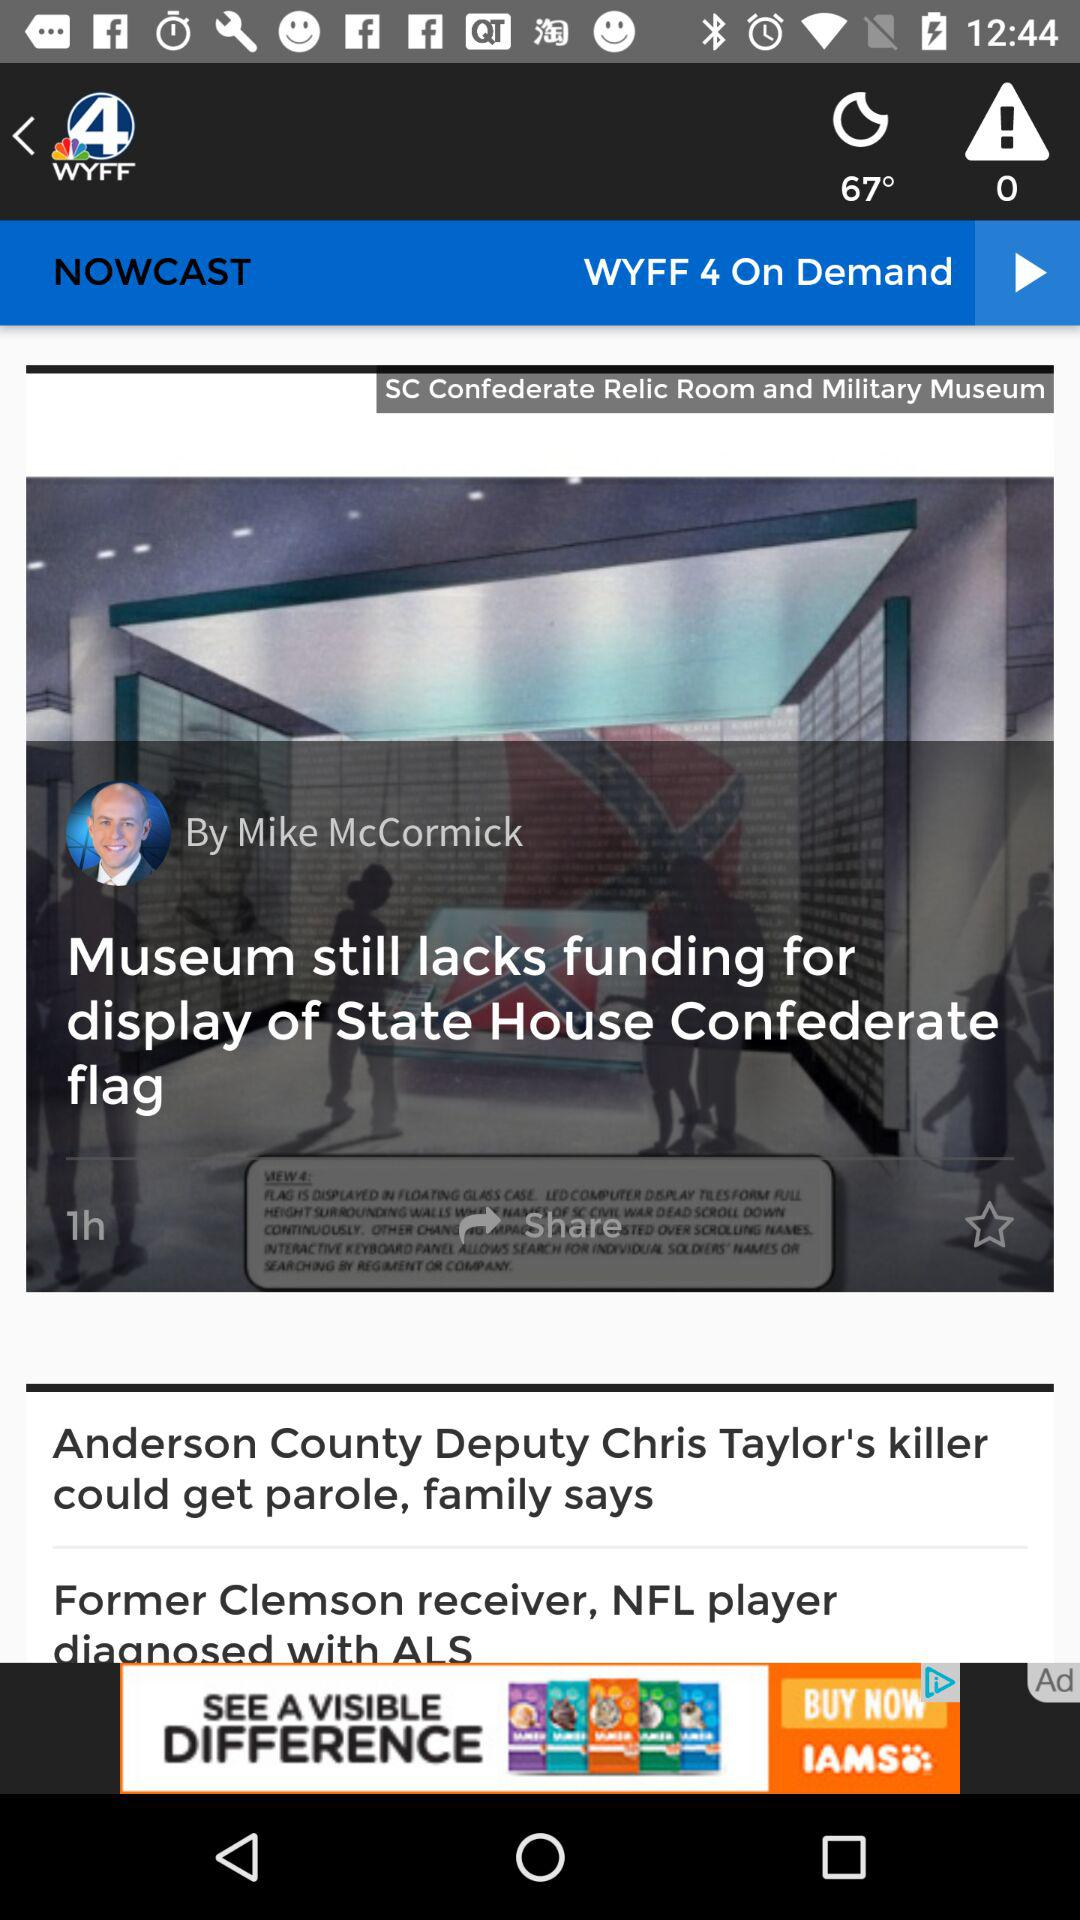What is the temperature? The temperature is 67°. 